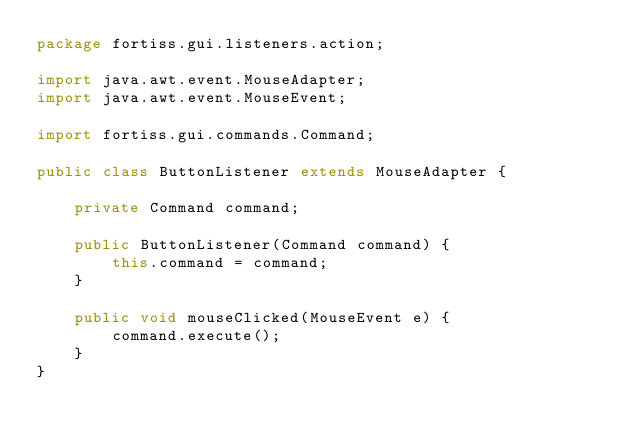Convert code to text. <code><loc_0><loc_0><loc_500><loc_500><_Java_>package fortiss.gui.listeners.action;

import java.awt.event.MouseAdapter;
import java.awt.event.MouseEvent;

import fortiss.gui.commands.Command;

public class ButtonListener extends MouseAdapter {
	
	private Command command;
	
	public ButtonListener(Command command) {
		this.command = command;
	}
	
	public void mouseClicked(MouseEvent e) {
		command.execute();
	}
}
</code> 